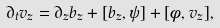Convert formula to latex. <formula><loc_0><loc_0><loc_500><loc_500>\partial _ { t } v _ { z } = \partial _ { z } b _ { z } + [ b _ { z } , \psi ] + [ \phi , v _ { z } ] ,</formula> 